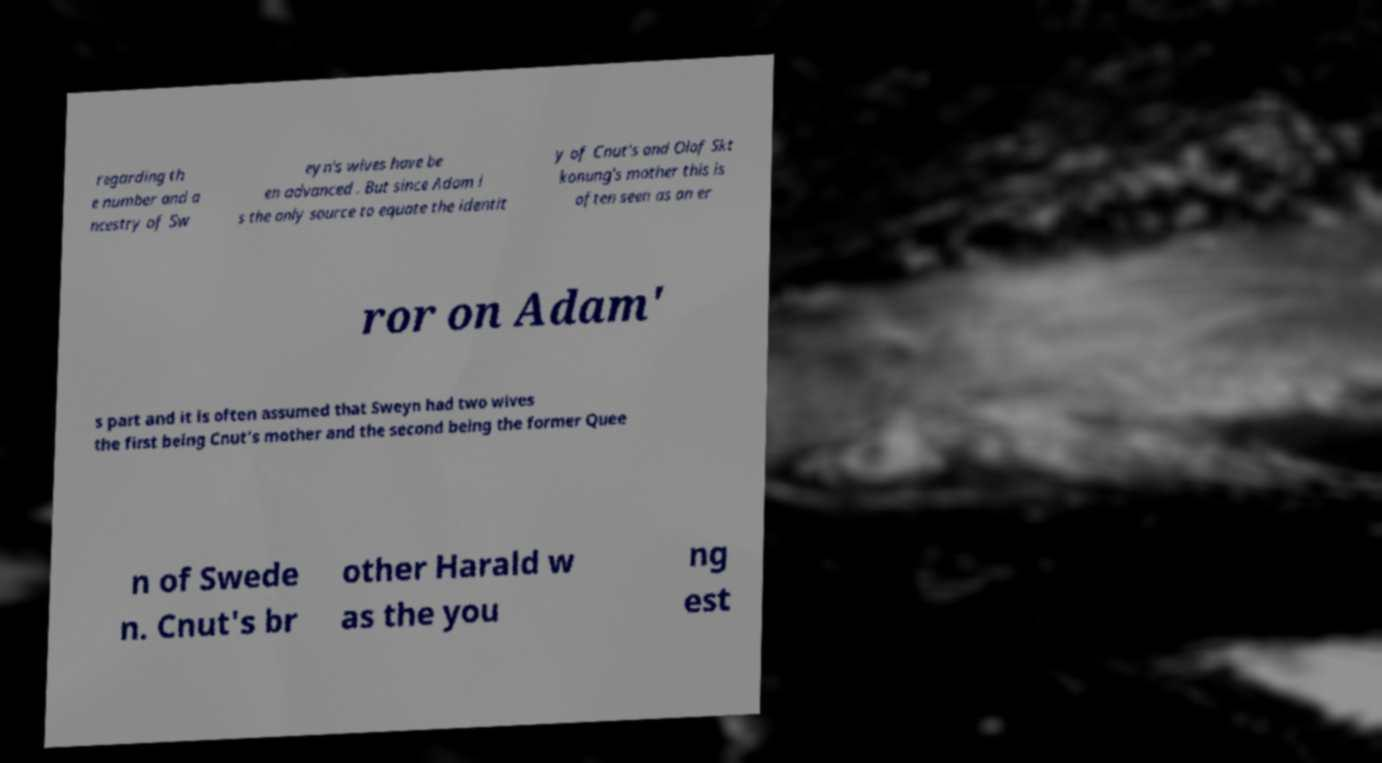Could you assist in decoding the text presented in this image and type it out clearly? regarding th e number and a ncestry of Sw eyn's wives have be en advanced . But since Adam i s the only source to equate the identit y of Cnut's and Olof Skt konung's mother this is often seen as an er ror on Adam' s part and it is often assumed that Sweyn had two wives the first being Cnut's mother and the second being the former Quee n of Swede n. Cnut's br other Harald w as the you ng est 